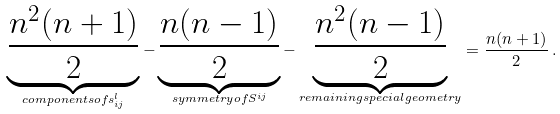Convert formula to latex. <formula><loc_0><loc_0><loc_500><loc_500>\underbrace { \frac { n ^ { 2 } ( n + 1 ) } { 2 } } _ { c o m p o n e n t s o f s _ { i j } ^ { l } } - \underbrace { \frac { n ( n - 1 ) } { 2 } } _ { s y m m e t r y o f S ^ { i j } } - \underbrace { \frac { n ^ { 2 } ( n - 1 ) } { 2 } } _ { r e m a i n i n g s p e c i a l g e o m e t r y } = \frac { n ( n + 1 ) } { 2 } \, .</formula> 